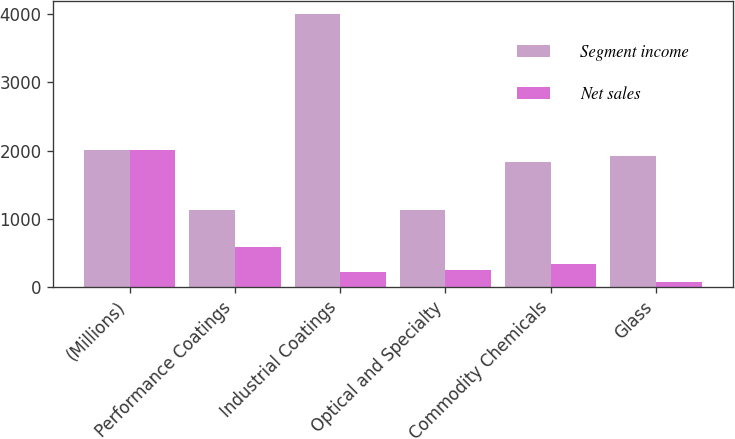Convert chart. <chart><loc_0><loc_0><loc_500><loc_500><stacked_bar_chart><ecel><fcel>(Millions)<fcel>Performance Coatings<fcel>Industrial Coatings<fcel>Optical and Specialty<fcel>Commodity Chemicals<fcel>Glass<nl><fcel>Segment income<fcel>2008<fcel>1134<fcel>3999<fcel>1134<fcel>1837<fcel>1914<nl><fcel>Net sales<fcel>2008<fcel>582<fcel>212<fcel>244<fcel>340<fcel>70<nl></chart> 